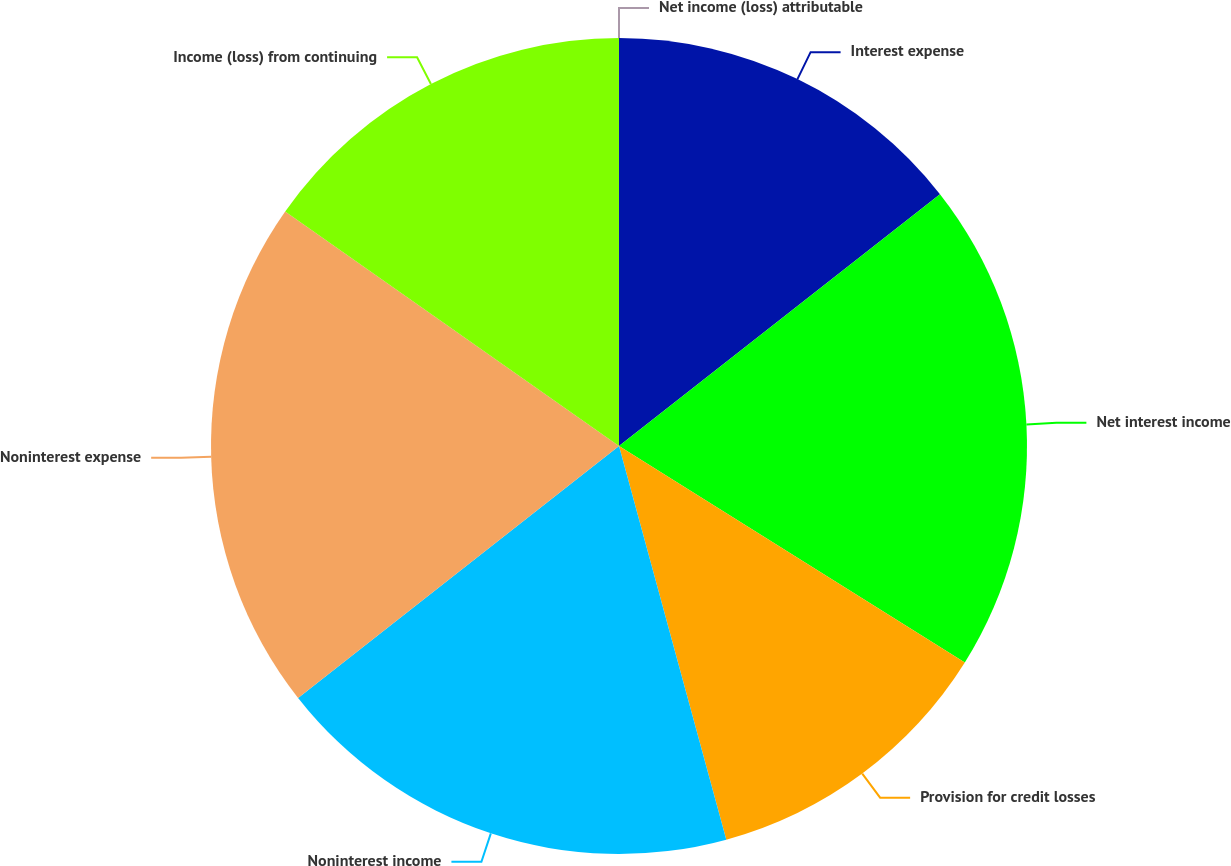Convert chart. <chart><loc_0><loc_0><loc_500><loc_500><pie_chart><fcel>Interest expense<fcel>Net interest income<fcel>Provision for credit losses<fcel>Noninterest income<fcel>Noninterest expense<fcel>Income (loss) from continuing<fcel>Net income (loss) attributable<nl><fcel>14.41%<fcel>19.49%<fcel>11.86%<fcel>18.64%<fcel>20.34%<fcel>15.25%<fcel>0.0%<nl></chart> 